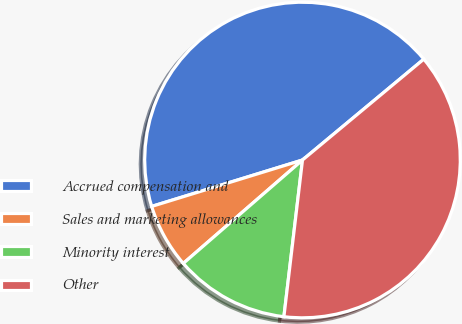<chart> <loc_0><loc_0><loc_500><loc_500><pie_chart><fcel>Accrued compensation and<fcel>Sales and marketing allowances<fcel>Minority interest<fcel>Other<nl><fcel>43.71%<fcel>6.62%<fcel>11.75%<fcel>37.92%<nl></chart> 